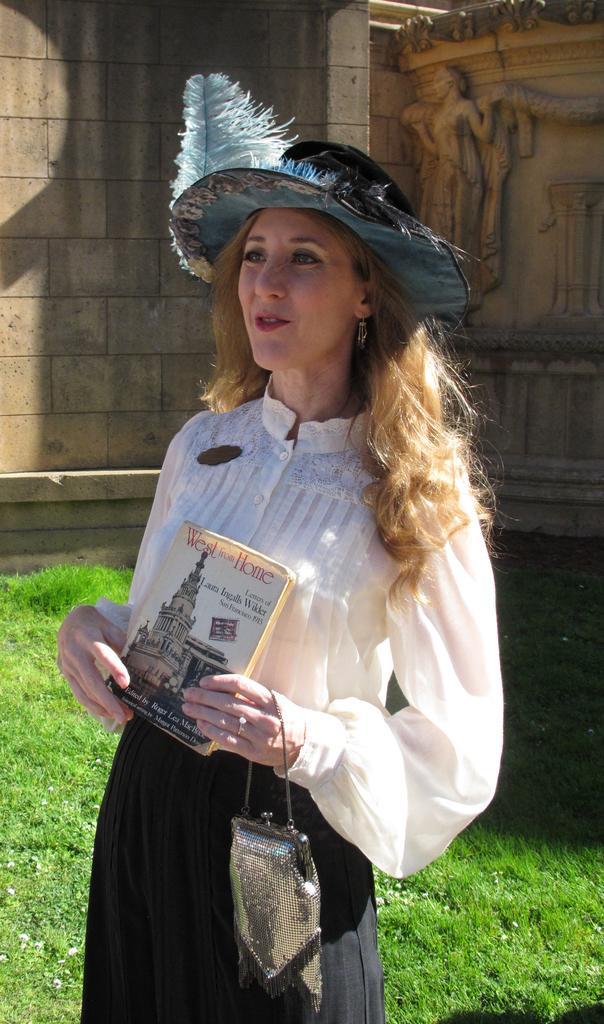Describe this image in one or two sentences. In the middle of the image a woman is standing and holding a bag and book. Behind her we can see grass and wall, on the wall we can see a sculpture. 